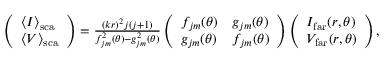<formula> <loc_0><loc_0><loc_500><loc_500>\begin{array} { r } { \left ( \begin{array} { l } { \langle I \rangle _ { s c a } } \\ { \langle V \rangle _ { s c a } } \end{array} \right ) = \frac { ( k r ) ^ { 2 } j ( j + 1 ) } { f _ { j m } ^ { 2 } ( \theta ) - g _ { j m } ^ { 2 } ( \theta ) } \left ( \begin{array} { l l } { f _ { j m } ( \theta ) } & { g _ { j m } ( \theta ) } \\ { g _ { j m } ( \theta ) } & { f _ { j m } ( \theta ) } \end{array} \right ) \left ( \begin{array} { l } { I _ { f a r } ( r , \theta ) } \\ { V _ { f a r } ( r , \theta ) } \end{array} \right ) , } \end{array}</formula> 